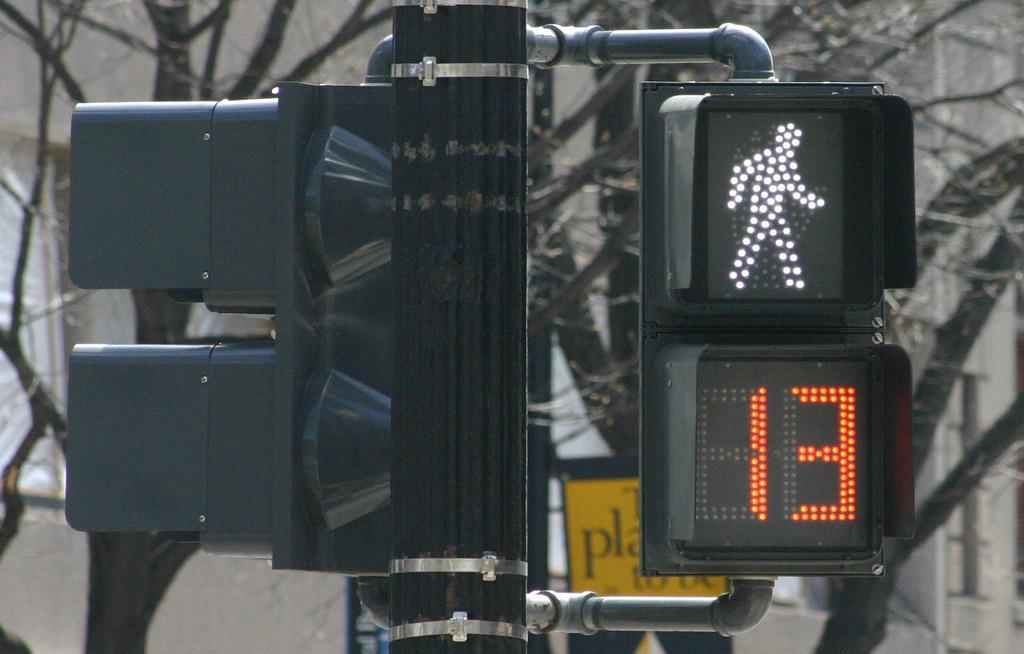Provide a one-sentence caption for the provided image. a street sign and walking sign is on for the next 13 seconds. 